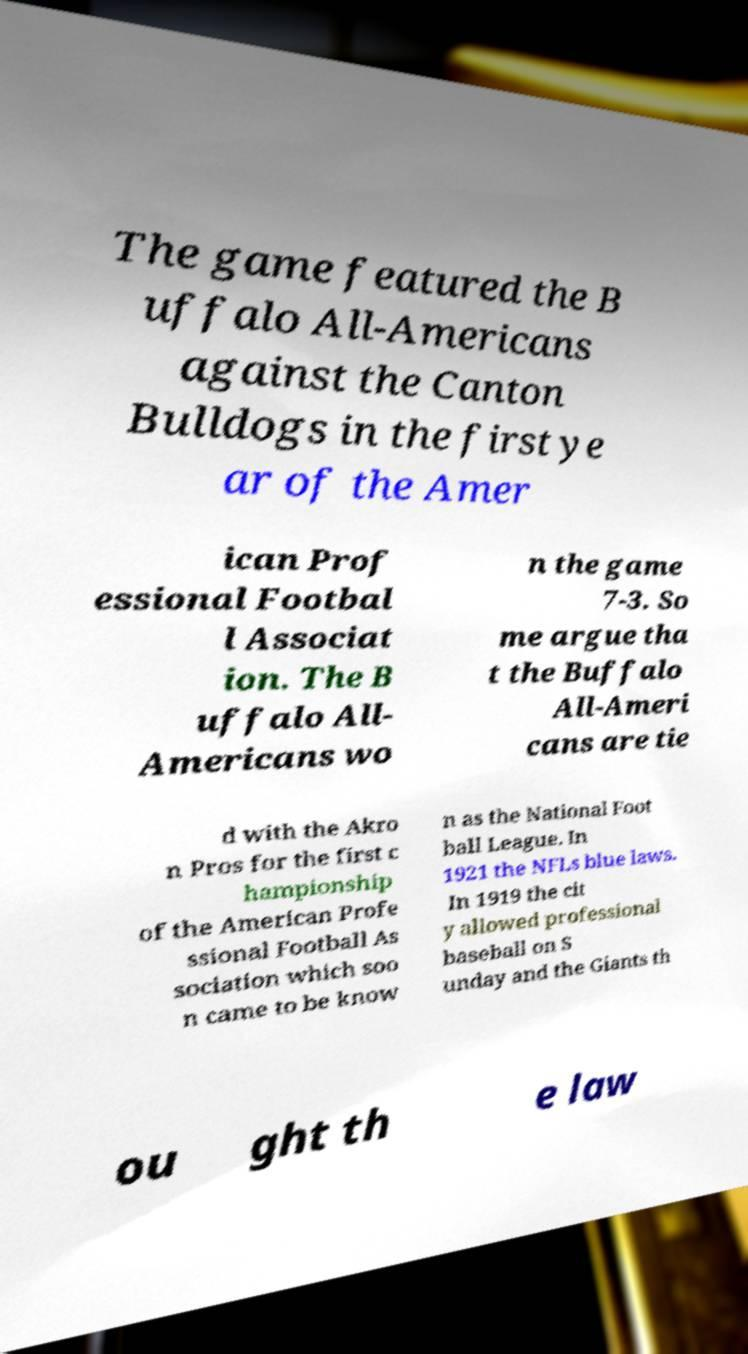Can you accurately transcribe the text from the provided image for me? The game featured the B uffalo All-Americans against the Canton Bulldogs in the first ye ar of the Amer ican Prof essional Footbal l Associat ion. The B uffalo All- Americans wo n the game 7-3. So me argue tha t the Buffalo All-Ameri cans are tie d with the Akro n Pros for the first c hampionship of the American Profe ssional Football As sociation which soo n came to be know n as the National Foot ball League. In 1921 the NFLs blue laws. In 1919 the cit y allowed professional baseball on S unday and the Giants th ou ght th e law 